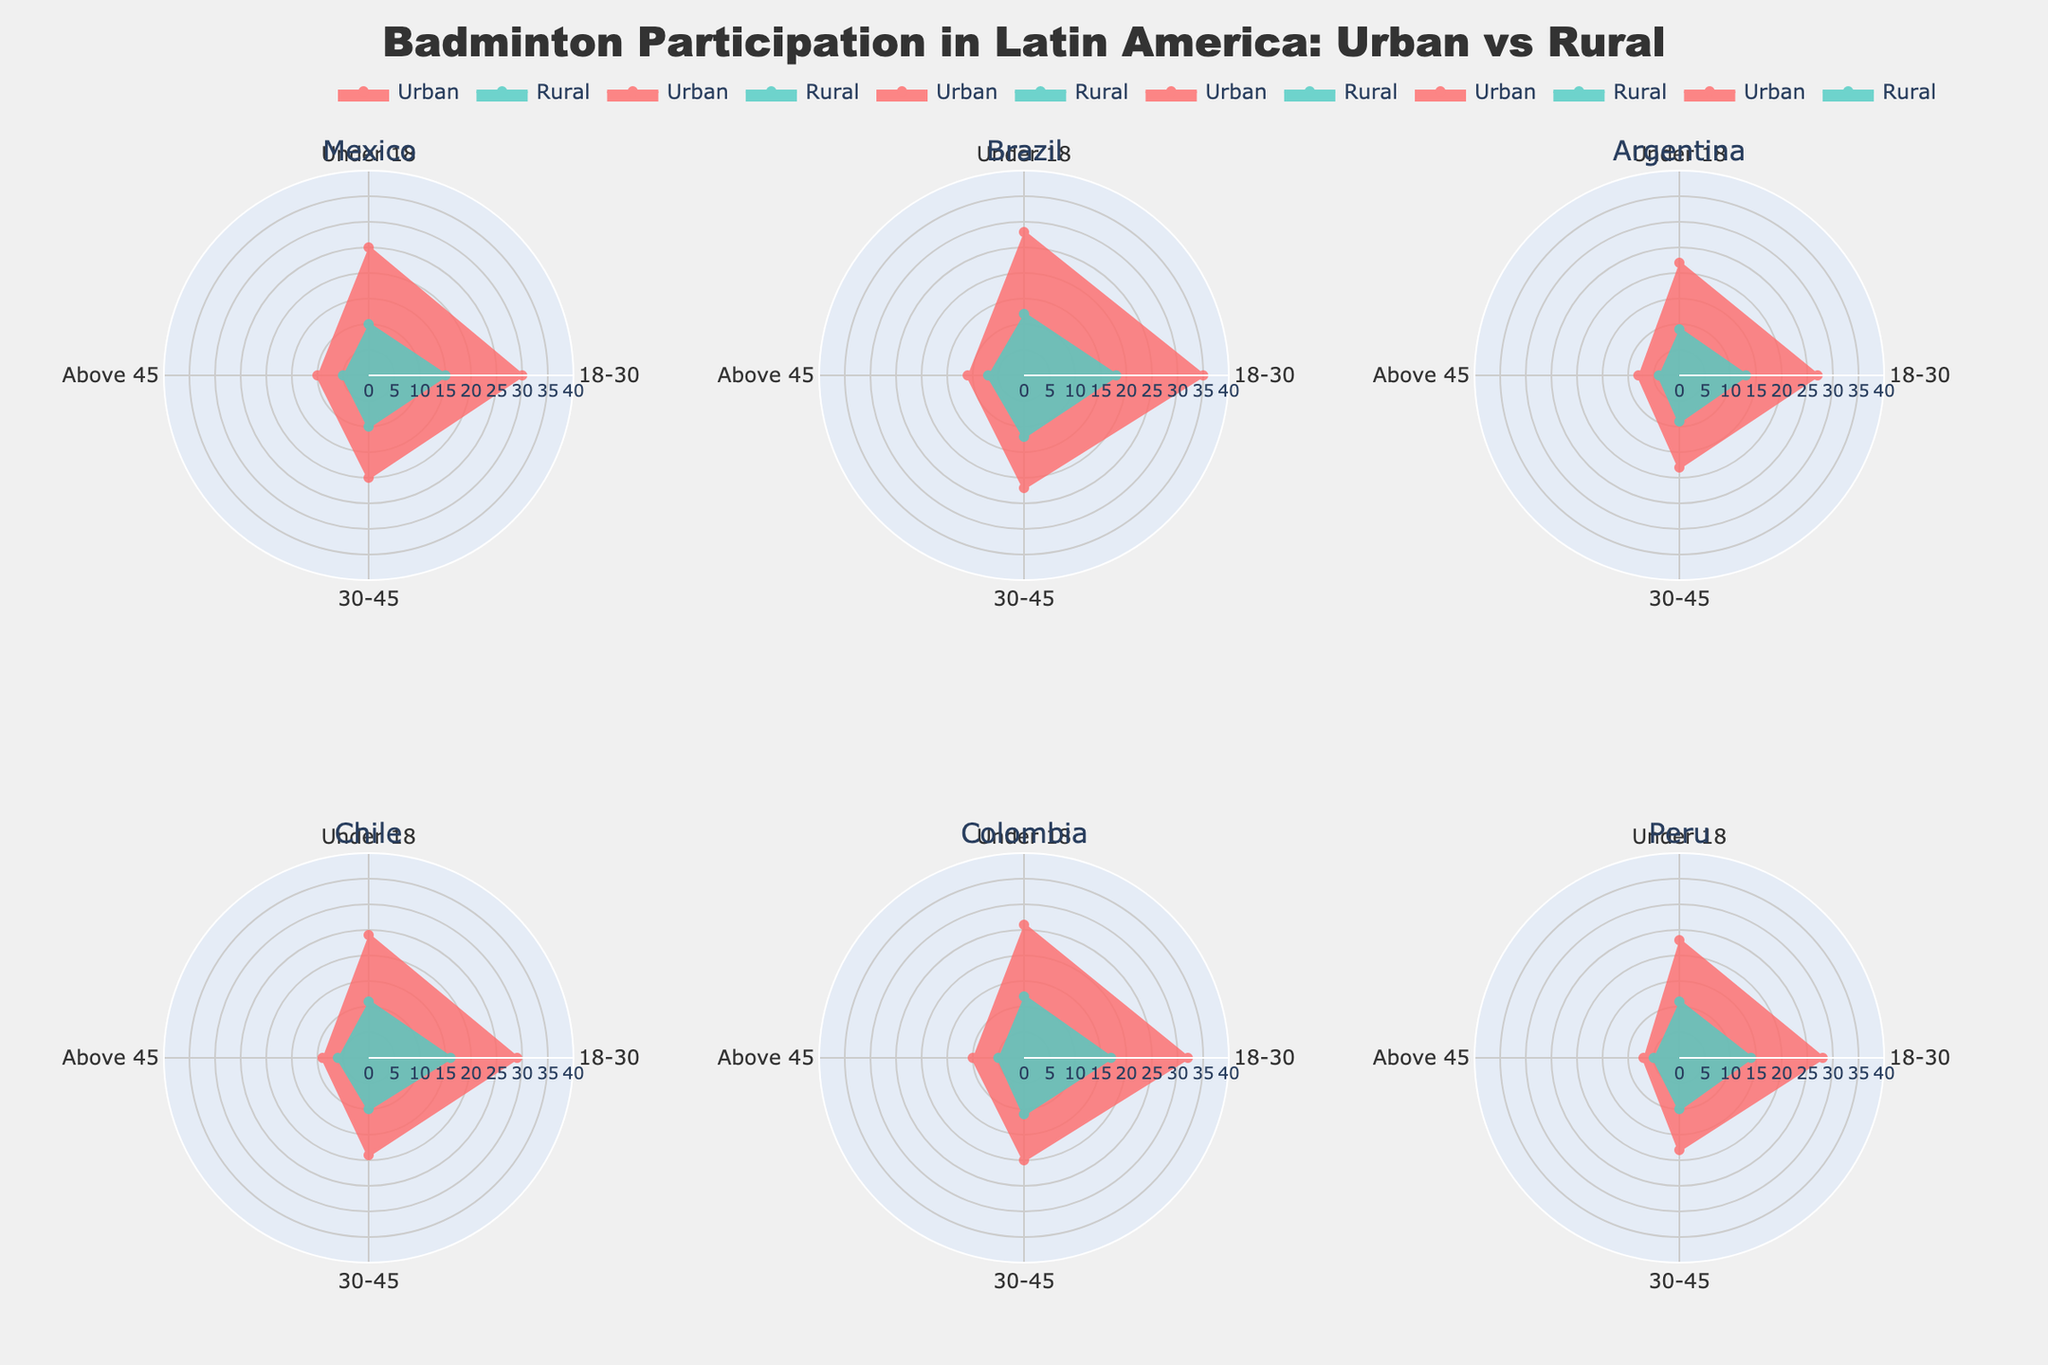What is the title of the figure? The title of the figure is typically displayed at the top and summarizes what the figure is about. In this case, it is about badminton participation in Latin America with a comparison between urban and rural areas.
Answer: Badminton Participation in Latin America: Urban vs Rural Which age group has the highest urban participation percentage in Brazil? To find this, we look at the subplot for Brazil and identify which age group has the longest radial line for the urban data.
Answer: 18-30 In Mexico, how does the rural participation for the 'Above 45' age group compare to the 'Under 18' age group? To answer this, we compare the length of the radial lines for rural participation in both age groups in the Mexico subplot. The 'Above 45' age group has a shorter line compared to the 'Under 18' group.
Answer: It is lower What is the difference in urban participation percentages between Colombia and Argentina for the '18-30' age group? We need to look at the radial lengths for the '18-30' age group in the Colombia and Argentina subplots and calculate the difference. Urban participation in Colombia for this age group is 32%, while in Argentina it is 27%. The difference is 32% - 27%.
Answer: 5% Which region shows a greater disparity between urban and rural participation for the '30-45' age group? We look at each subplot and identify the regions where the gap between the urban and rural radial lines for the '30-45' age group is the largest. Brazil has a disparity of 22% (urban) - 12% (rural) = 10%, while Chile has 19% (urban) - 10% (rural) = 9%, and so on.
Answer: Brazil Are urban participation rates generally higher than rural participation rates across all regions and age groups? We examine each subplot and compare the radial lines representing urban and rural participation rates for each age group. In all instances, the urban participation line is higher than the rural one.
Answer: Yes In Peru, what is the rural participation percentage for the 'Under 18' age group? To find this, locate the 'Under 18' segment in the Peru subplot and identify the length of the radial line for rural participation.
Answer: 11% Which region has the lowest urban participation percentage for the '18-30' age group? To find this, compare the urban radial lines for the '18-30' age group across all subplots.
Answer: Argentina What is the average urban participation percentage for the '30-45' age group across all regions? Add the urban participation rates for '30-45' age group across all regions and divide by the number of regions. (Mexico: 20, Brazil: 22, Argentina: 18, Chile: 19, Colombia: 20, Peru: 18) Average = (20+22+18+19+20+18)/6 = 19.5%
Answer: 19.5% How does the urban participation for 'Under 18' compare across Mexico, Brazil, and Colombia? To answer, we check the urban participation percentages for 'Under 18' in the subplots of Mexico, Brazil, and Colombia. Mexico: 25%, Brazil: 28%, Colombia: 26%.
Answer: Brazil is the highest, followed by Colombia, and then Mexico 